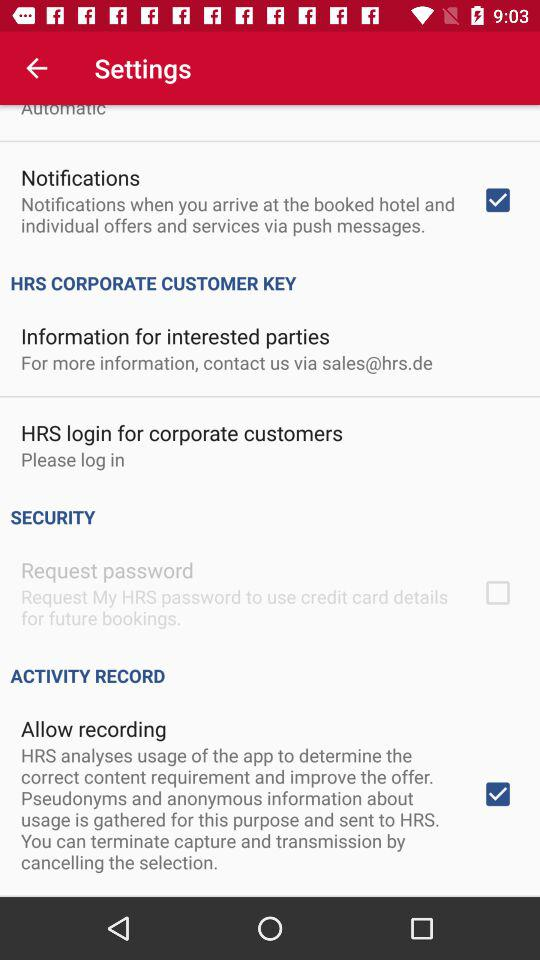What is the status of "Notifications" setting? The status of "Notifications" setting is "on". 